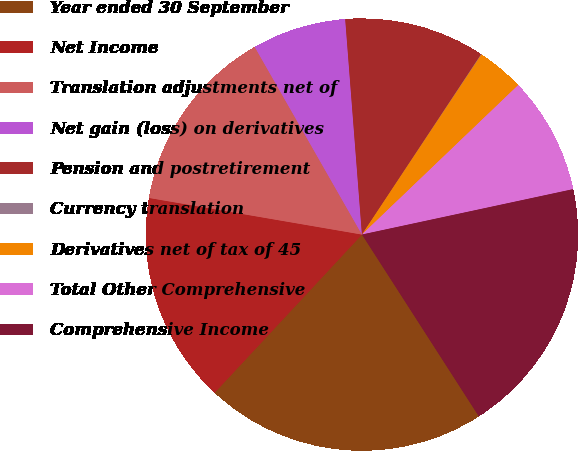Convert chart to OTSL. <chart><loc_0><loc_0><loc_500><loc_500><pie_chart><fcel>Year ended 30 September<fcel>Net Income<fcel>Translation adjustments net of<fcel>Net gain (loss) on derivatives<fcel>Pension and postretirement<fcel>Currency translation<fcel>Derivatives net of tax of 45<fcel>Total Other Comprehensive<fcel>Comprehensive Income<nl><fcel>21.03%<fcel>15.78%<fcel>14.03%<fcel>7.03%<fcel>10.53%<fcel>0.03%<fcel>3.53%<fcel>8.78%<fcel>19.28%<nl></chart> 